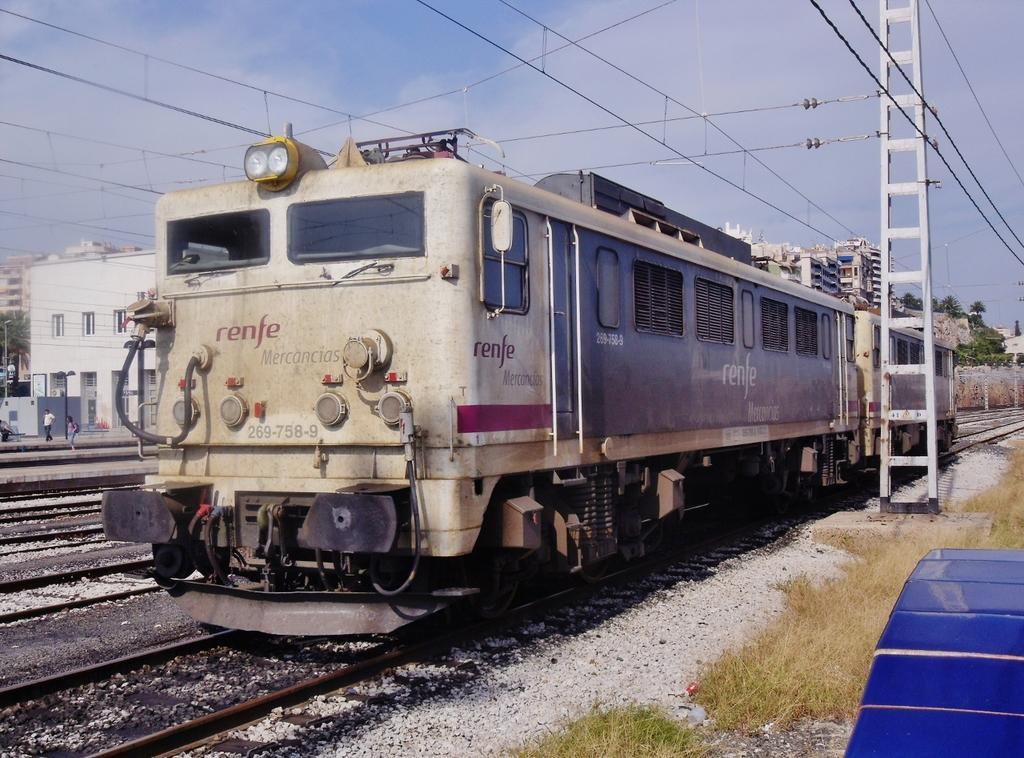In one or two sentences, can you explain what this image depicts? In the middle of this image there is a train on the railway track. On the right side, I can see the grass on the ground and there is a blue color object. Here I can see few poles along with the wires. On the left side there are few buildings and two persons are walking on the platform. At the top of the image I can see the sky. 